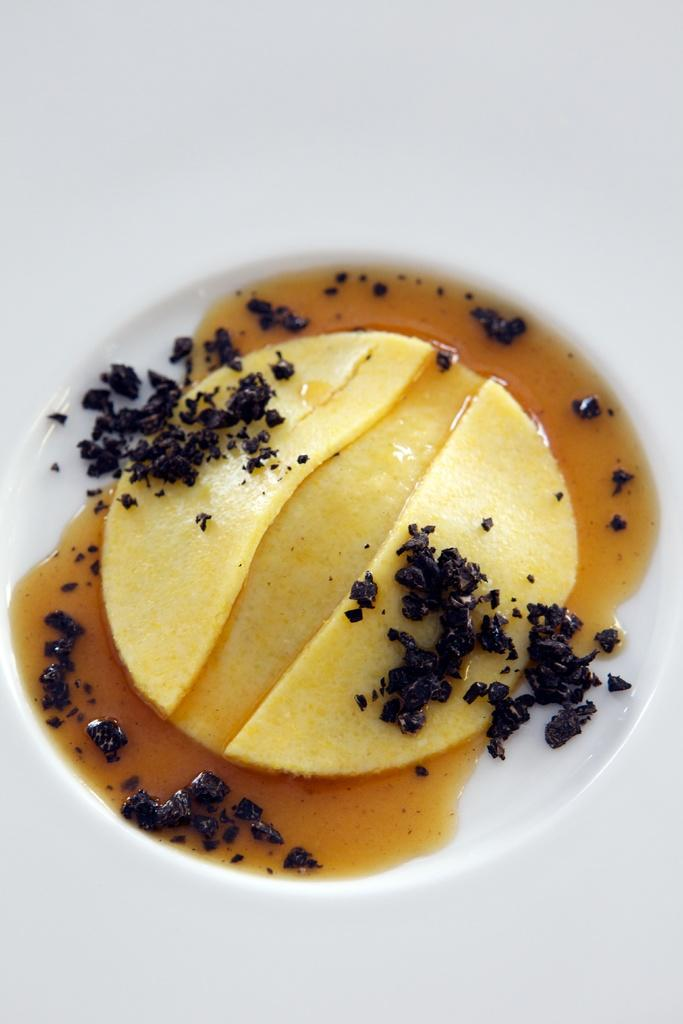What is the main subject of the image? There is a food item in the image. How is the food item presented in the image? The food item is in a plate. What type of underwear is visible in the image? There is no underwear present in the image. What sign can be seen on the plate in the image? There is no sign visible on the plate in the image. 